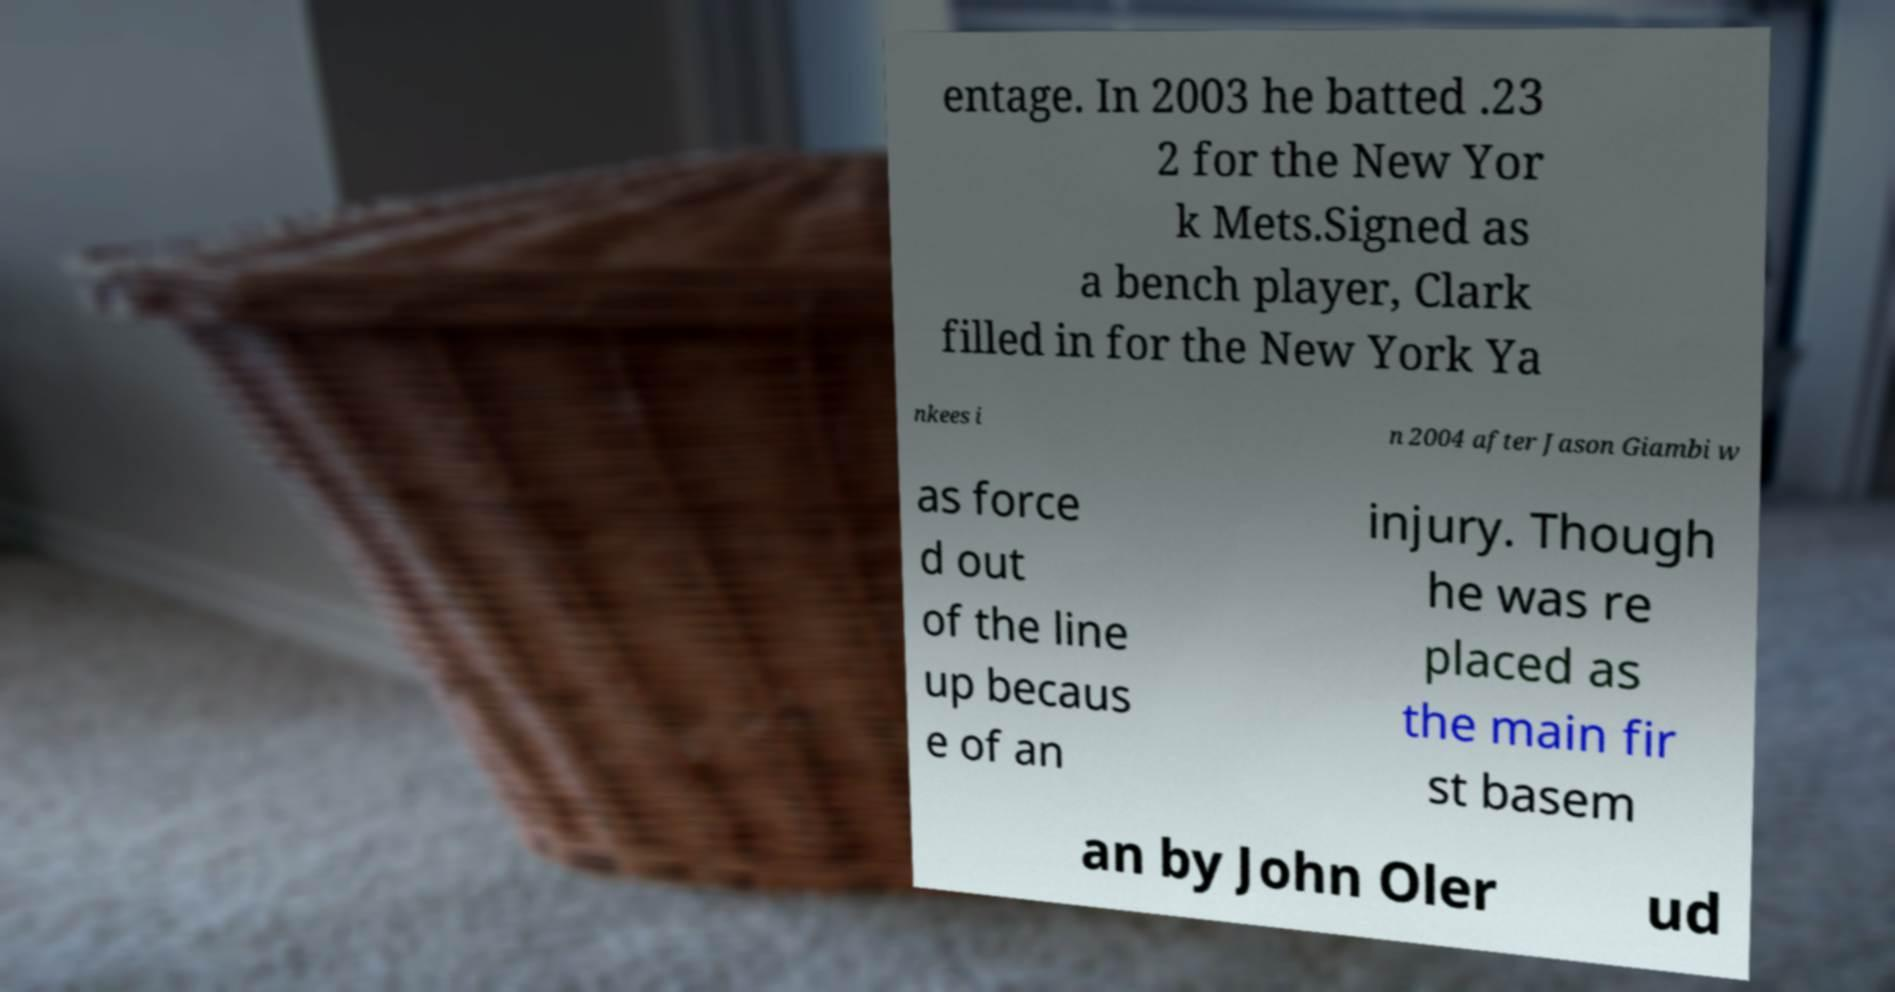Please read and relay the text visible in this image. What does it say? entage. In 2003 he batted .23 2 for the New Yor k Mets.Signed as a bench player, Clark filled in for the New York Ya nkees i n 2004 after Jason Giambi w as force d out of the line up becaus e of an injury. Though he was re placed as the main fir st basem an by John Oler ud 